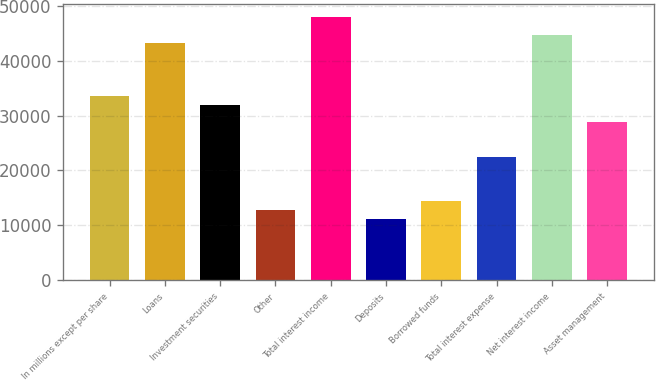Convert chart. <chart><loc_0><loc_0><loc_500><loc_500><bar_chart><fcel>In millions except per share<fcel>Loans<fcel>Investment securities<fcel>Other<fcel>Total interest income<fcel>Deposits<fcel>Borrowed funds<fcel>Total interest expense<fcel>Net interest income<fcel>Asset management<nl><fcel>33617<fcel>43219.8<fcel>32016.6<fcel>12811<fcel>48021.2<fcel>11210.6<fcel>14411.5<fcel>22413.8<fcel>44820.2<fcel>28815.6<nl></chart> 